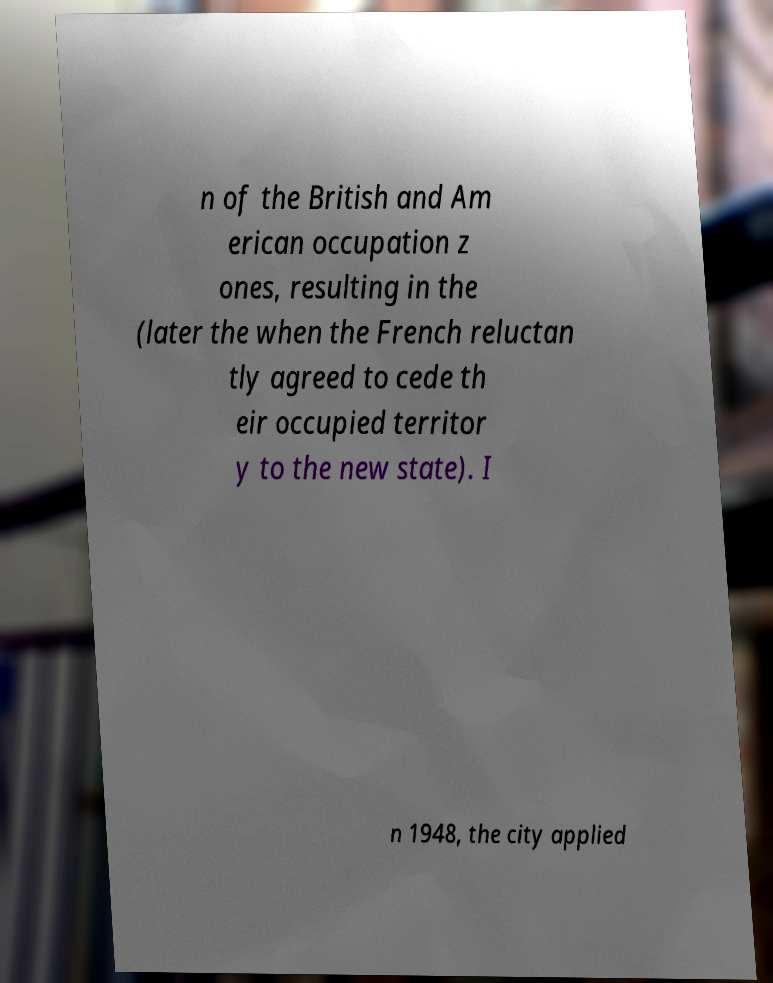For documentation purposes, I need the text within this image transcribed. Could you provide that? n of the British and Am erican occupation z ones, resulting in the (later the when the French reluctan tly agreed to cede th eir occupied territor y to the new state). I n 1948, the city applied 